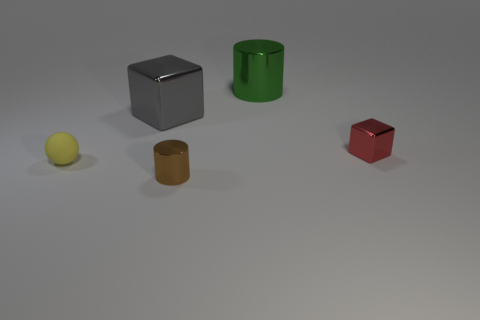Does the gray cube have the same size as the cube that is to the right of the big green cylinder?
Your answer should be very brief. No. There is a metallic thing that is in front of the large cube and behind the yellow thing; what is its size?
Provide a short and direct response. Small. Are there any other blocks that have the same color as the large shiny cube?
Provide a short and direct response. No. The cube left of the cylinder that is in front of the gray metal thing is what color?
Your answer should be compact. Gray. Are there fewer small brown cylinders behind the big gray shiny cube than cylinders on the left side of the yellow thing?
Ensure brevity in your answer.  No. Do the ball and the gray metal object have the same size?
Your answer should be very brief. No. What is the shape of the shiny object that is both to the right of the gray block and behind the red metal object?
Give a very brief answer. Cylinder. What number of other tiny things have the same material as the yellow object?
Give a very brief answer. 0. There is a metal cylinder that is behind the tiny yellow sphere; what number of matte things are in front of it?
Your response must be concise. 1. What is the shape of the tiny thing that is to the left of the large thing that is on the left side of the metal cylinder that is behind the big shiny cube?
Your answer should be compact. Sphere. 